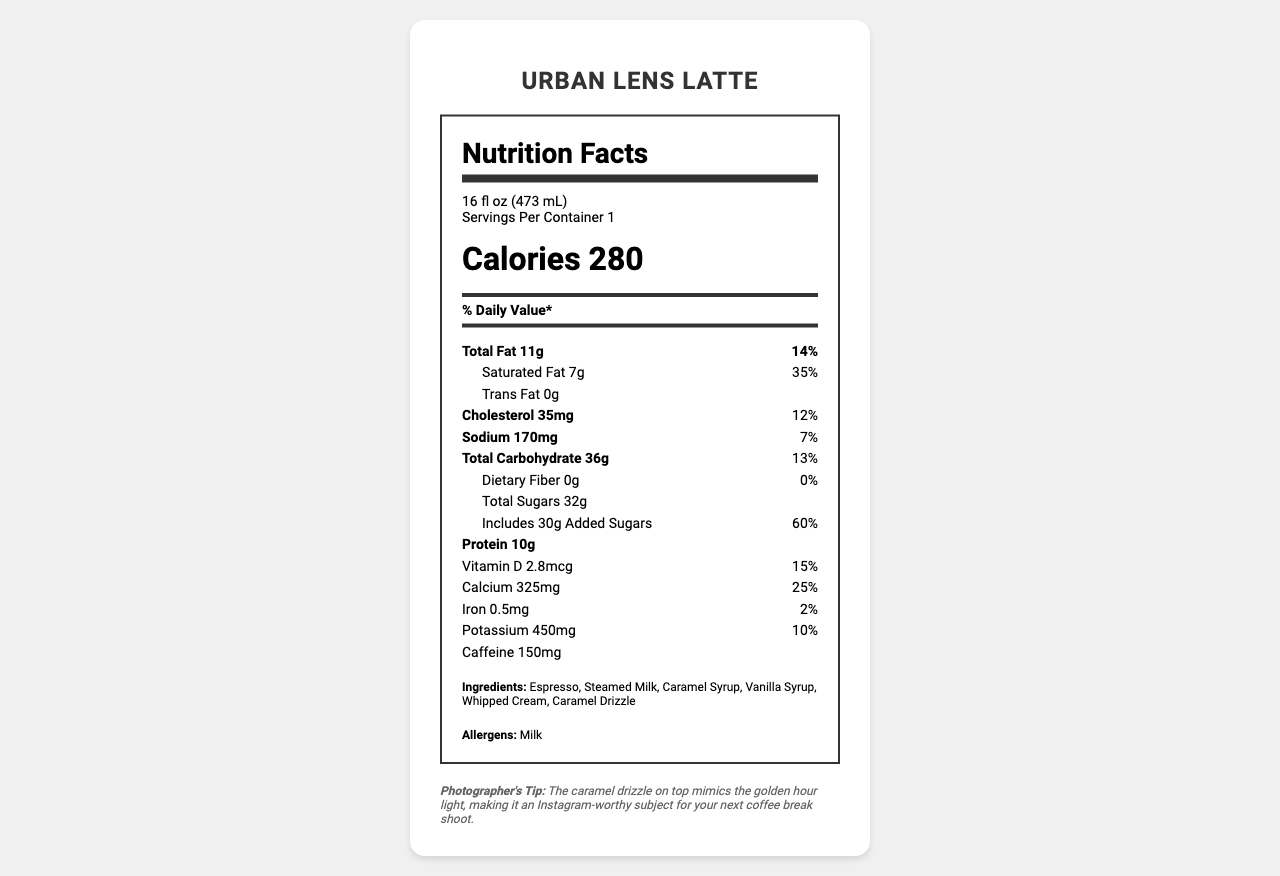who is the intended audience for the Urban Lens Latte? The description mentions that the Urban Lens Latte is crafted for urban photographers who need a delicious energy boost during long photo shoots.
Answer: Urban photographers how many servings are in one container of the Urban Lens Latte? The serving information specifies that there is 1 serving per container.
Answer: 1 how much caffeine is in the Urban Lens Latte? The nutrition label explicitly states the caffeine content as 150 mg.
Answer: 150 mg what is the total amount of fat in the Urban Lens Latte? The nutrients section lists Total Fat as 11 g.
Answer: 11 g which ingredient is responsible for the added sugars in the Urban Lens Latte? A. Espresso B. Steamed Milk C. Caramel Syrup D. Whipped Cream The caramel syrup is the likely ingredient responsible for the added sugars.
Answer: C how many grams of total sugars are there in the Urban Lens Latte? The nutrition label states that the total sugars amount to 32 g.
Answer: 32 g what is the daily value percentage of saturated fat in the Urban Lens Latte? The document specifies that the daily value percentage for saturated fat is 35%.
Answer: 35% is this product suitable for someone with a milk allergy? The allergen information section clearly states the presence of milk.
Answer: No which nutrient has the highest daily value percentage in the Urban Lens Latte? A. Total Fat B. Saturated Fat C. Added Sugars The added sugars have a daily value of 60%, which is the highest.
Answer: C describe the main idea of the document The document provides detailed nutritional information, ingredients, and a description that highlights the product's appeal to its target audience of urban photographers.
Answer: The document is a nutrition facts label for the Urban Lens Latte, a specialty coffee drink. It details the serving size, nutritional content, ingredients, allergens, and includes a description targeted at urban photographers. It also provides a photographer's tip about the aesthetic appeal of the caramel drizzle on the latte. how much protein does the Urban Lens Latte contain? The nutrition label indicates that the protein content is 10 g.
Answer: 10 g what is the daily value percentage of calcium in the Urban Lens Latte? The document lists the daily value percentage of calcium as 25%.
Answer: 25% is the total carbohydrate value higher than the total fat value? The total carbohydrate value is 36 g, which is higher than the total fat value of 11 g.
Answer: Yes how many milligrams of iron are there in the Urban Lens Latte? The nutrition label mentions that the iron content is 0.5 mg.
Answer: 0.5 mg which of the following is not an ingredient in the Urban Lens Latte? A. Espresso B. Steamed Milk C. Chocolate Syrup D. Caramel Drizzle The list of ingredients does not include Chocolate Syrup.
Answer: C what is the recommended daily intake percentage of vitamin D provided by the Urban Lens Latte? The label states that the latte provides 15% of the recommended daily intake of vitamin D.
Answer: 15% how many calories are in one serving of the Urban Lens Latte? The document specifies that one serving contains 280 calories.
Answer: 280 what is the significance of the caramel drizzle according to the description? The photographer's tip states that the caramel drizzle on top mimics the golden hour light, making it an Instagram-worthy subject.
Answer: Mimics the golden hour light how much sodium is in the Urban Lens Latte? The nutrition label indicates that the sodium content is 170 mg.
Answer: 170 mg is the energy boost provided by the Urban Lens Latte due to its caffeine content? While caffeine contributes to the energy boost, the document also mentions other ingredients like sugars that can contribute to an energy boost, making it difficult to attribute it solely to caffeine.
Answer: Cannot be determined 